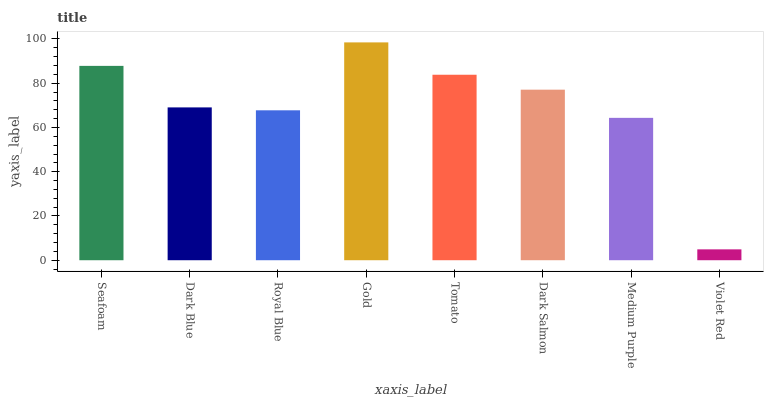Is Violet Red the minimum?
Answer yes or no. Yes. Is Gold the maximum?
Answer yes or no. Yes. Is Dark Blue the minimum?
Answer yes or no. No. Is Dark Blue the maximum?
Answer yes or no. No. Is Seafoam greater than Dark Blue?
Answer yes or no. Yes. Is Dark Blue less than Seafoam?
Answer yes or no. Yes. Is Dark Blue greater than Seafoam?
Answer yes or no. No. Is Seafoam less than Dark Blue?
Answer yes or no. No. Is Dark Salmon the high median?
Answer yes or no. Yes. Is Dark Blue the low median?
Answer yes or no. Yes. Is Royal Blue the high median?
Answer yes or no. No. Is Violet Red the low median?
Answer yes or no. No. 